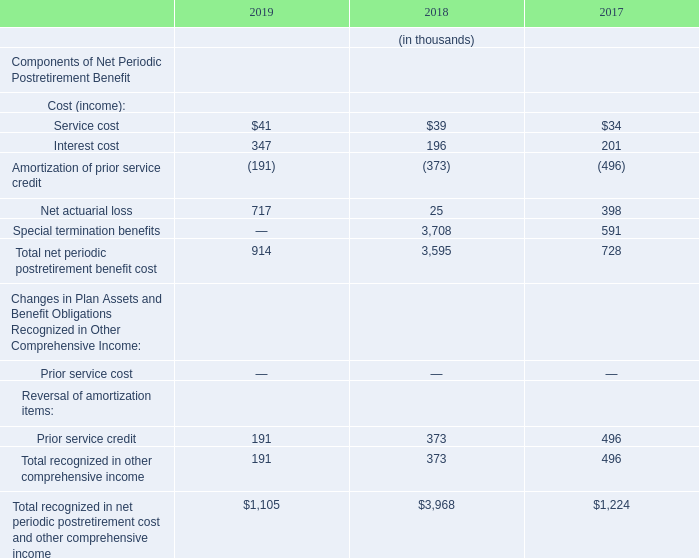Expense
For the years ended December 31, 2019, 2018, and 2017, Teradyne’s net periodic postretirement benefit cost (income) was comprised of the following:
What was the service cost in 2019?
Answer scale should be: thousand. $41. What was the interest cost in 2019?
Answer scale should be: thousand. 347. For which years was  Teradyne’s net periodic postretirement benefit cost (income) calculated? 2019, 2018, 2017. In which year was service cost the largest? 41>39>34
Answer: 2019. What was the change in service cost in 2018 from 2017?
Answer scale should be: thousand. 39-34
Answer: 5. What was the percentage change in service cost in 2018 from 2017?
Answer scale should be: percent. (39-34)/34
Answer: 14.71. 